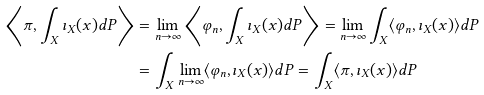<formula> <loc_0><loc_0><loc_500><loc_500>\left \langle \pi , \int _ { X } \imath _ { X } ( x ) d P \right \rangle & = \lim _ { n \to \infty } \left \langle \varphi _ { n } , \int _ { X } \imath _ { X } ( x ) d P \right \rangle = \lim _ { n \to \infty } \int _ { X } \langle \varphi _ { n } , \imath _ { X } ( x ) \rangle d P \\ & = \int _ { X } \lim _ { n \to \infty } \langle \varphi _ { n } , \imath _ { X } ( x ) \rangle d P = \int _ { X } \langle \pi , \imath _ { X } ( x ) \rangle d P</formula> 